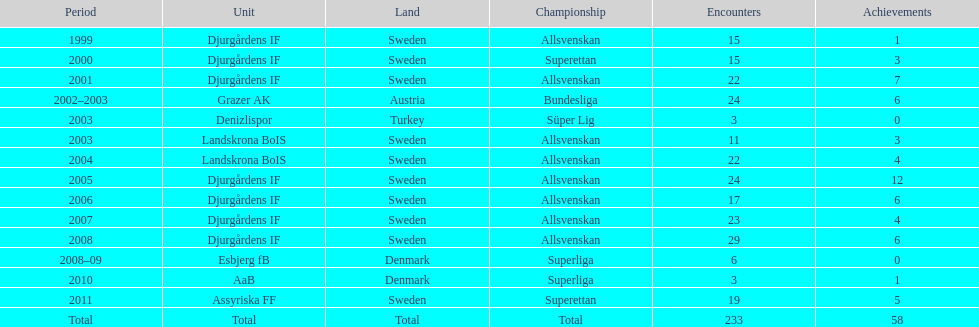What season has the most goals? 2005. 